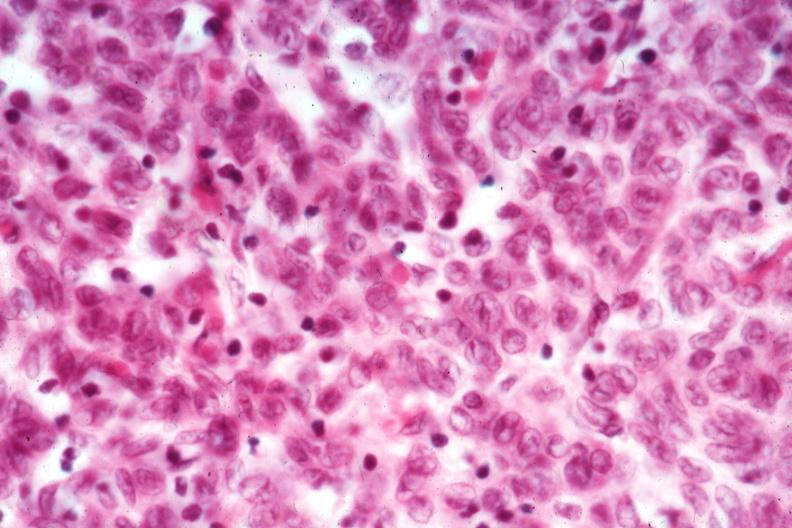s thymoma present?
Answer the question using a single word or phrase. Yes 